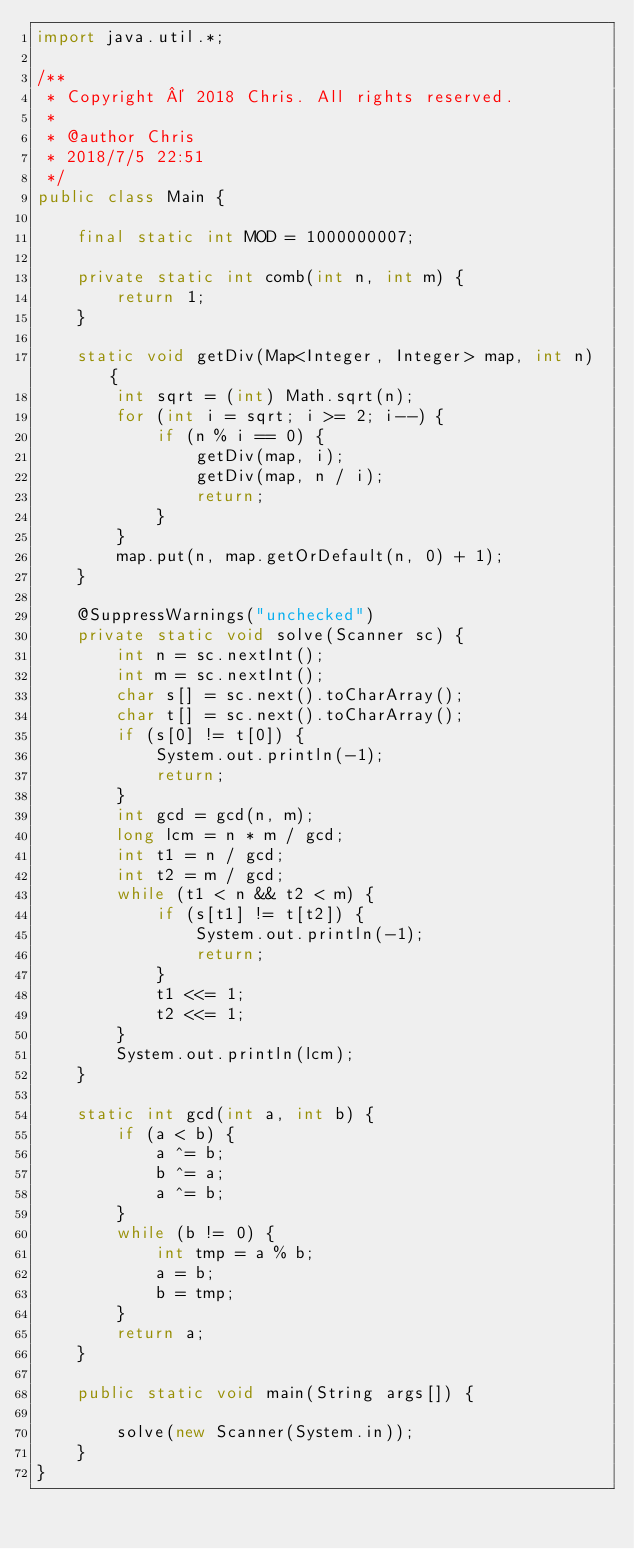<code> <loc_0><loc_0><loc_500><loc_500><_Java_>import java.util.*;

/**
 * Copyright © 2018 Chris. All rights reserved.
 *
 * @author Chris
 * 2018/7/5 22:51
 */
public class Main {

    final static int MOD = 1000000007;

    private static int comb(int n, int m) {
        return 1;
    }

    static void getDiv(Map<Integer, Integer> map, int n) {
        int sqrt = (int) Math.sqrt(n);
        for (int i = sqrt; i >= 2; i--) {
            if (n % i == 0) {
                getDiv(map, i);
                getDiv(map, n / i);
                return;
            }
        }
        map.put(n, map.getOrDefault(n, 0) + 1);
    }

    @SuppressWarnings("unchecked")
    private static void solve(Scanner sc) {
        int n = sc.nextInt();
        int m = sc.nextInt();
        char s[] = sc.next().toCharArray();
        char t[] = sc.next().toCharArray();
        if (s[0] != t[0]) {
            System.out.println(-1);
            return;
        }
        int gcd = gcd(n, m);
        long lcm = n * m / gcd;
        int t1 = n / gcd;
        int t2 = m / gcd;
        while (t1 < n && t2 < m) {
            if (s[t1] != t[t2]) {
                System.out.println(-1);
                return;
            }
            t1 <<= 1;
            t2 <<= 1;
        }
        System.out.println(lcm);
    }

    static int gcd(int a, int b) {
        if (a < b) {
            a ^= b;
            b ^= a;
            a ^= b;
        }
        while (b != 0) {
            int tmp = a % b;
            a = b;
            b = tmp;
        }
        return a;
    }

    public static void main(String args[]) {

        solve(new Scanner(System.in));
    }
}
</code> 